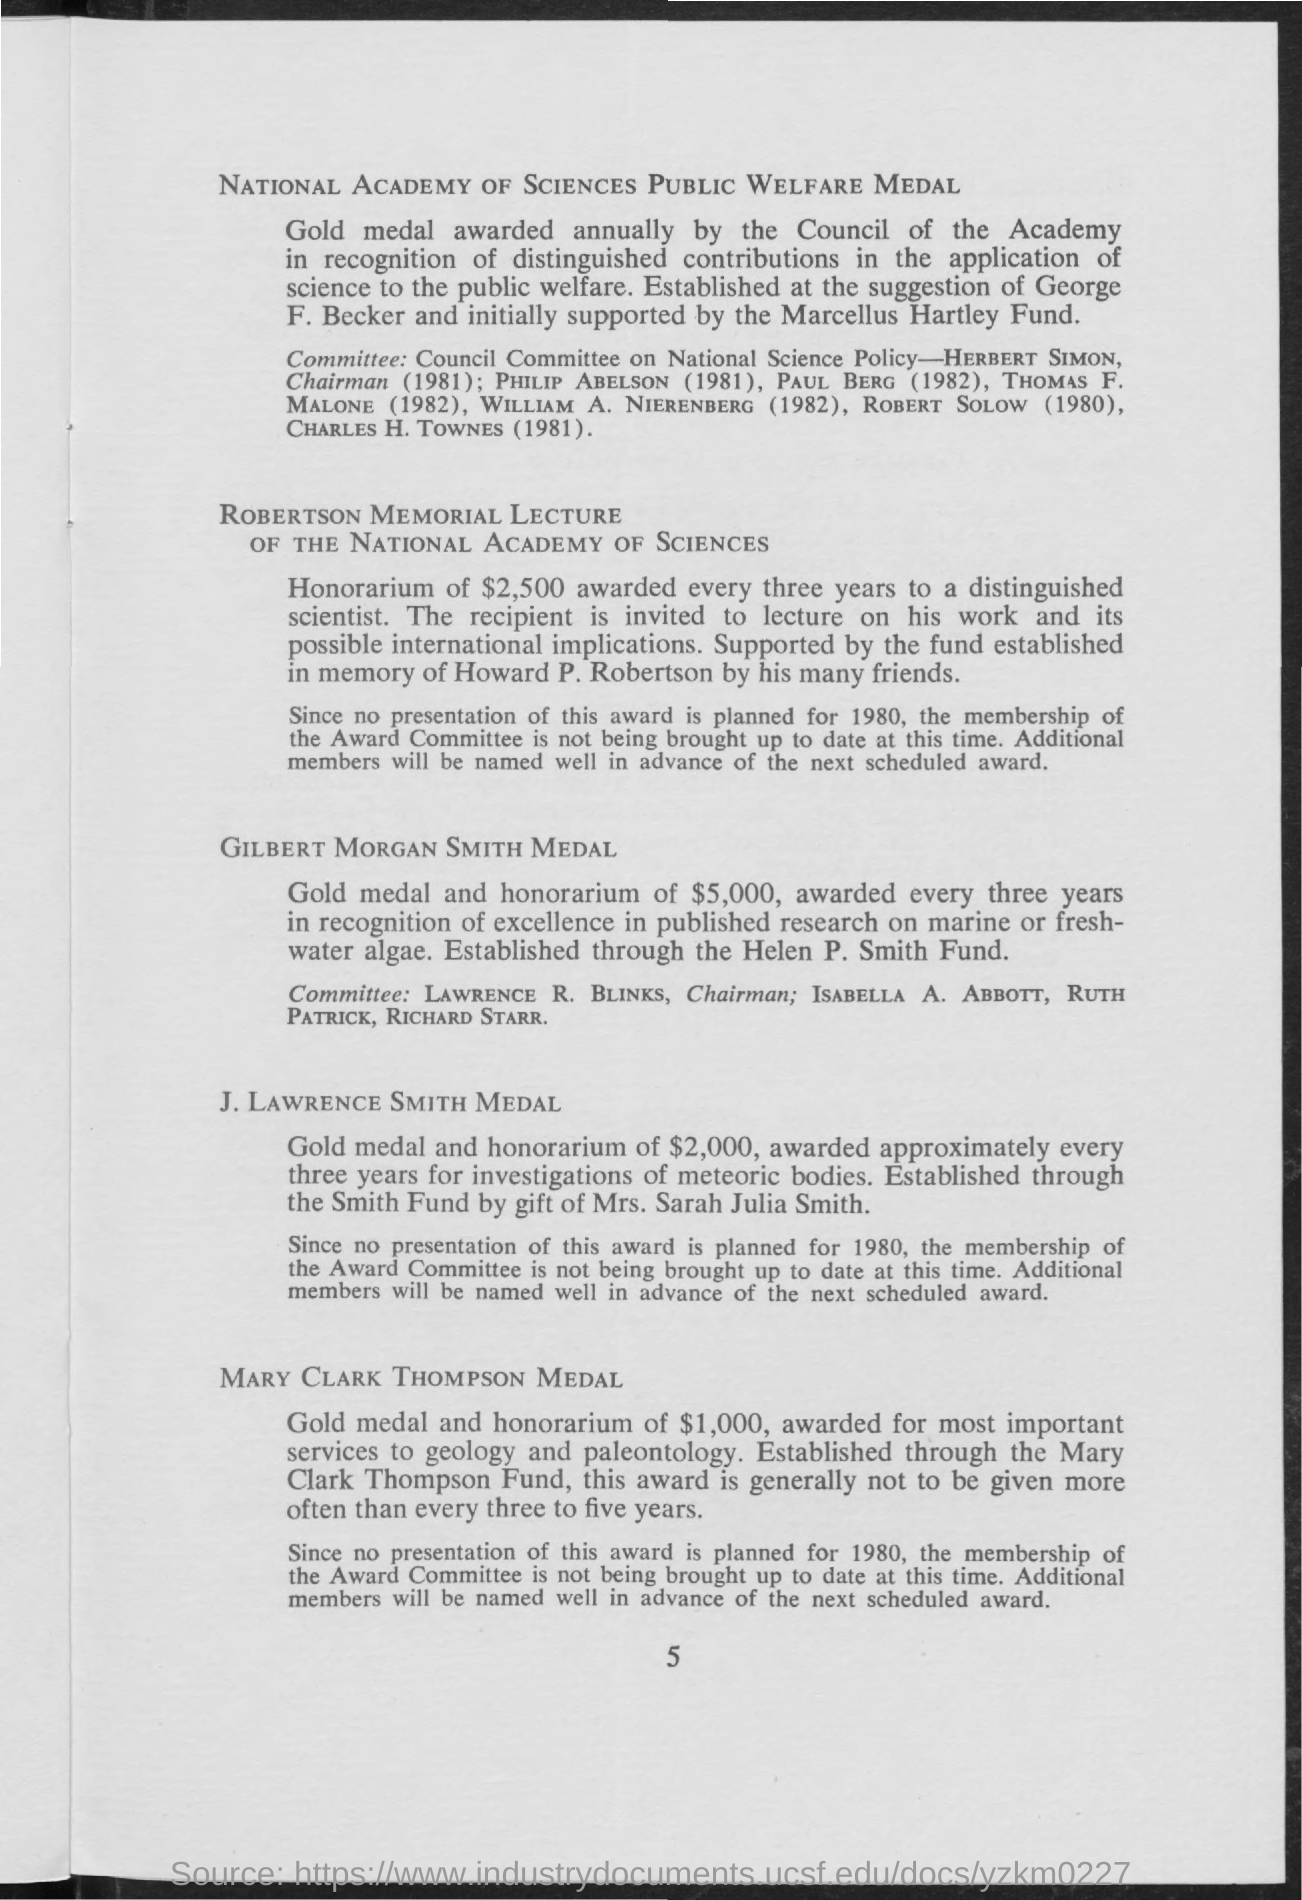Specify some key components in this picture. The Gilbert Morgan Smith Medal is awarded to recognize and honor significant contributions to the field of marine or fresh-water algae research. The Mary Clark Thompson Medal awards a gold medal and an honorarium of $1,000 to the recipient. 